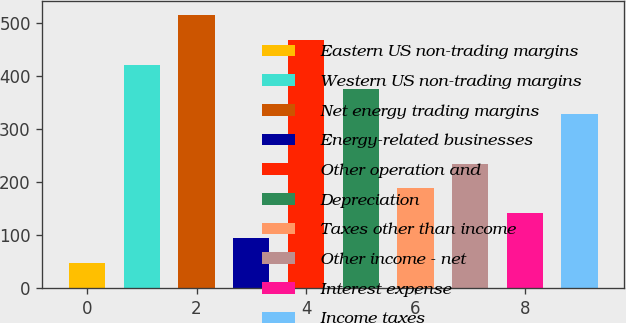Convert chart. <chart><loc_0><loc_0><loc_500><loc_500><bar_chart><fcel>Eastern US non-trading margins<fcel>Western US non-trading margins<fcel>Net energy trading margins<fcel>Energy-related businesses<fcel>Other operation and<fcel>Depreciation<fcel>Taxes other than income<fcel>Other income - net<fcel>Interest expense<fcel>Income taxes<nl><fcel>47.8<fcel>422.2<fcel>515.8<fcel>94.6<fcel>469<fcel>375.4<fcel>188.2<fcel>235<fcel>141.4<fcel>328.6<nl></chart> 